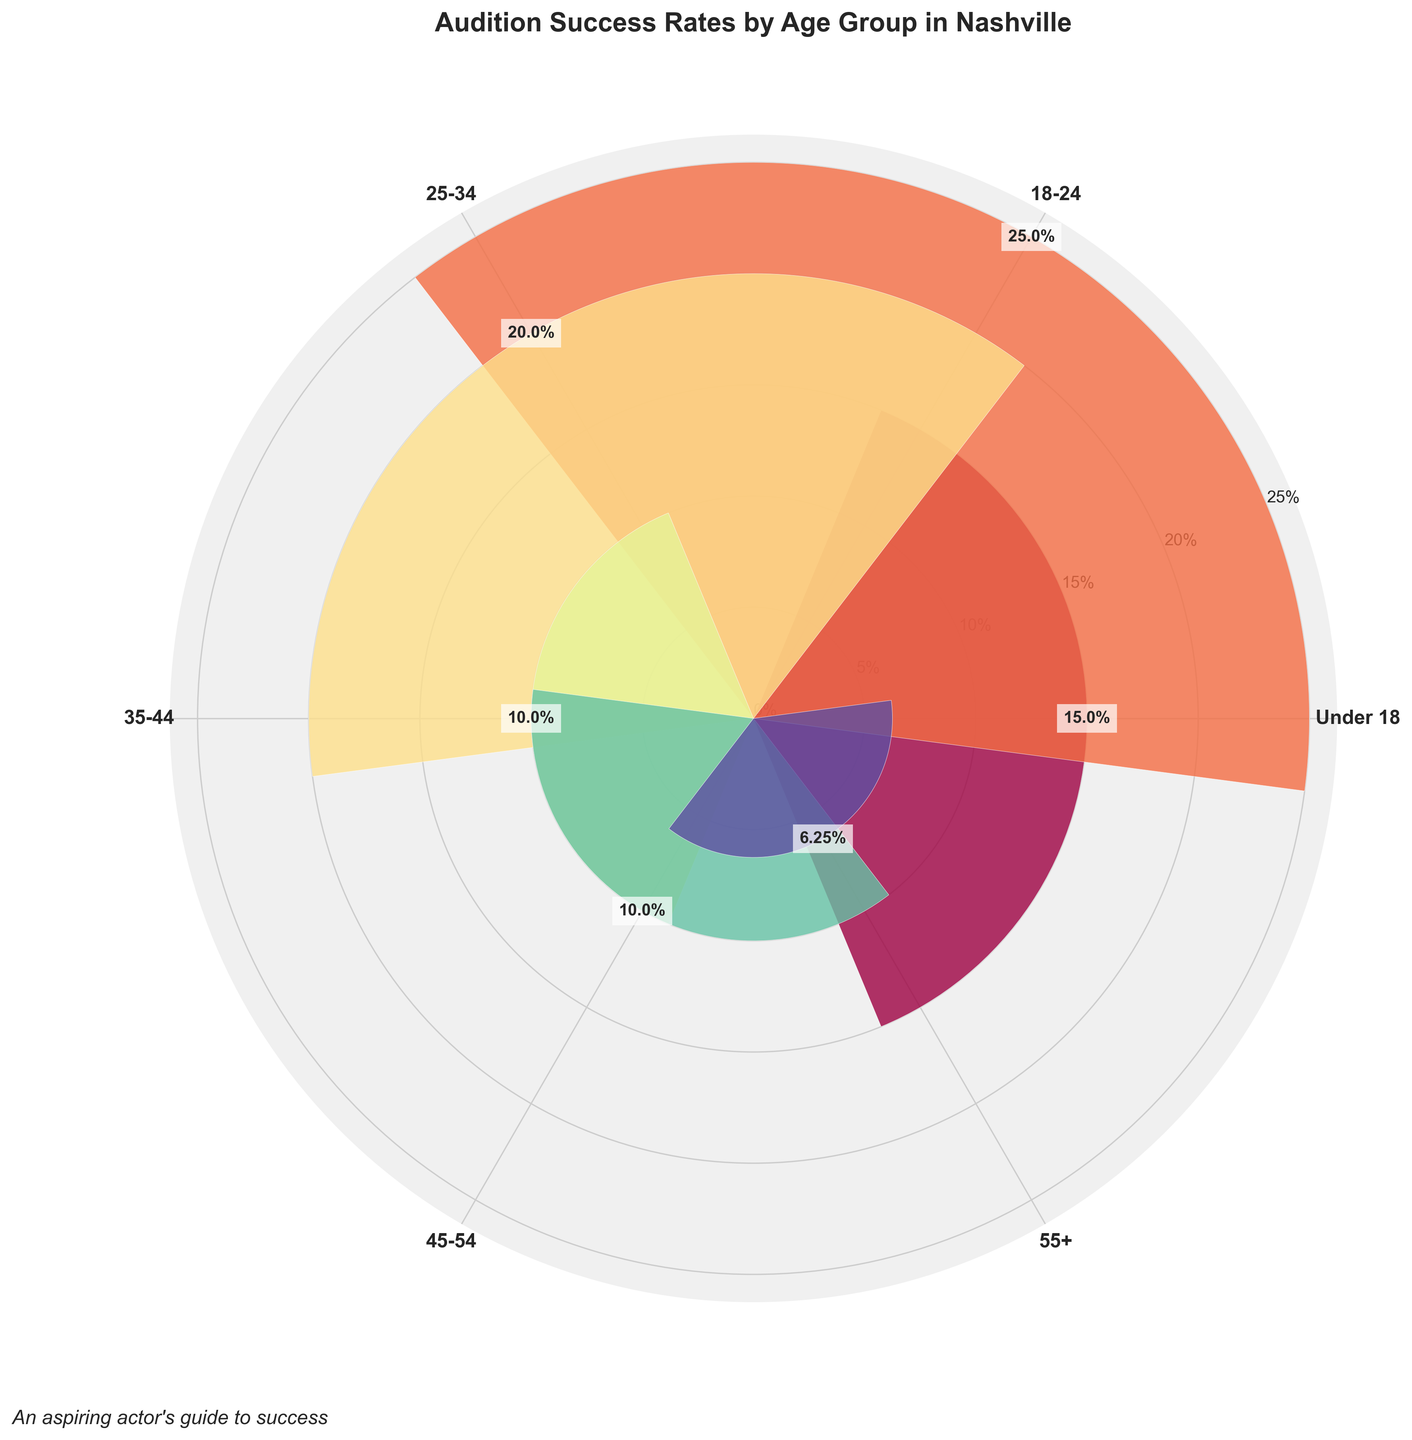What's the title of the figure? The title of the figure can be found at the top of the chart, usually in bold or larger font, providing an overview of what the chart is about.
Answer: "Audition Success Rates by Age Group in Nashville" Which age group has the highest audition success rate? By examining the lengths of the bars on the radial chart, the bar with the highest length corresponds to the highest success rate.
Answer: 18-24 Which two age groups have the same success rate? Reviewing the bar lengths and the data labels, look for age groups with bars of equal lengths or the same percentage label.
Answer: 35-44 and 45-54 What is the success rate for the 55+ age group? Locate the bar corresponding to the 55+ age group and read the data label or the length of the bar representing the success rate.
Answer: 6.25% How many age groups have a success rate less than 15%? Count the number of bars with lengths corresponding to success rates below 15% by checking the data labels or positions on the radial scale.
Answer: 4 What is the average success rate across all age groups? Sum the success rates for all age groups and then divide by the number of age groups: (15 + 25 + 20 + 10 + 10 + 6.25) / 6.
Answer: \( \approx 14.38\% \) What's the difference in success rates between the 18-24 and 55+ age groups? Subtract the success rate of the 55+ age group from that of the 18-24 age group: 25% - 6.25%.
Answer: 18.75% Which age group has the smallest success rate? Look for the shortest bar on the rose chart or the lowest percentage label.
Answer: 55+ Comparing the age groups 25-34 and 35-44, which has a higher success rate and by how much? Check the success rates for 25-34 and 35-44, then find the difference: 20% - 10%.
Answer: 25-34 by 10% 